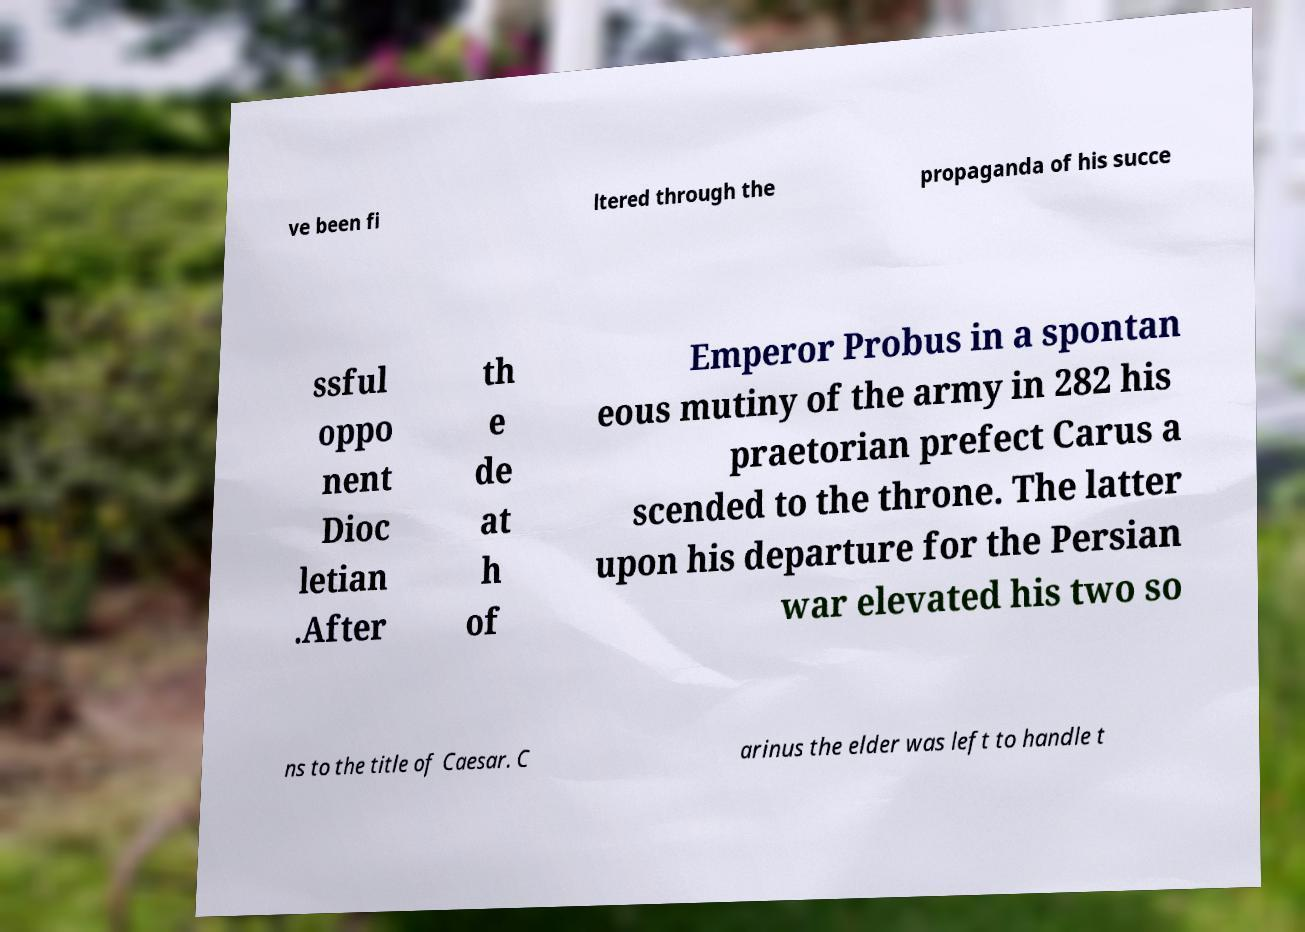Can you read and provide the text displayed in the image?This photo seems to have some interesting text. Can you extract and type it out for me? ve been fi ltered through the propaganda of his succe ssful oppo nent Dioc letian .After th e de at h of Emperor Probus in a spontan eous mutiny of the army in 282 his praetorian prefect Carus a scended to the throne. The latter upon his departure for the Persian war elevated his two so ns to the title of Caesar. C arinus the elder was left to handle t 